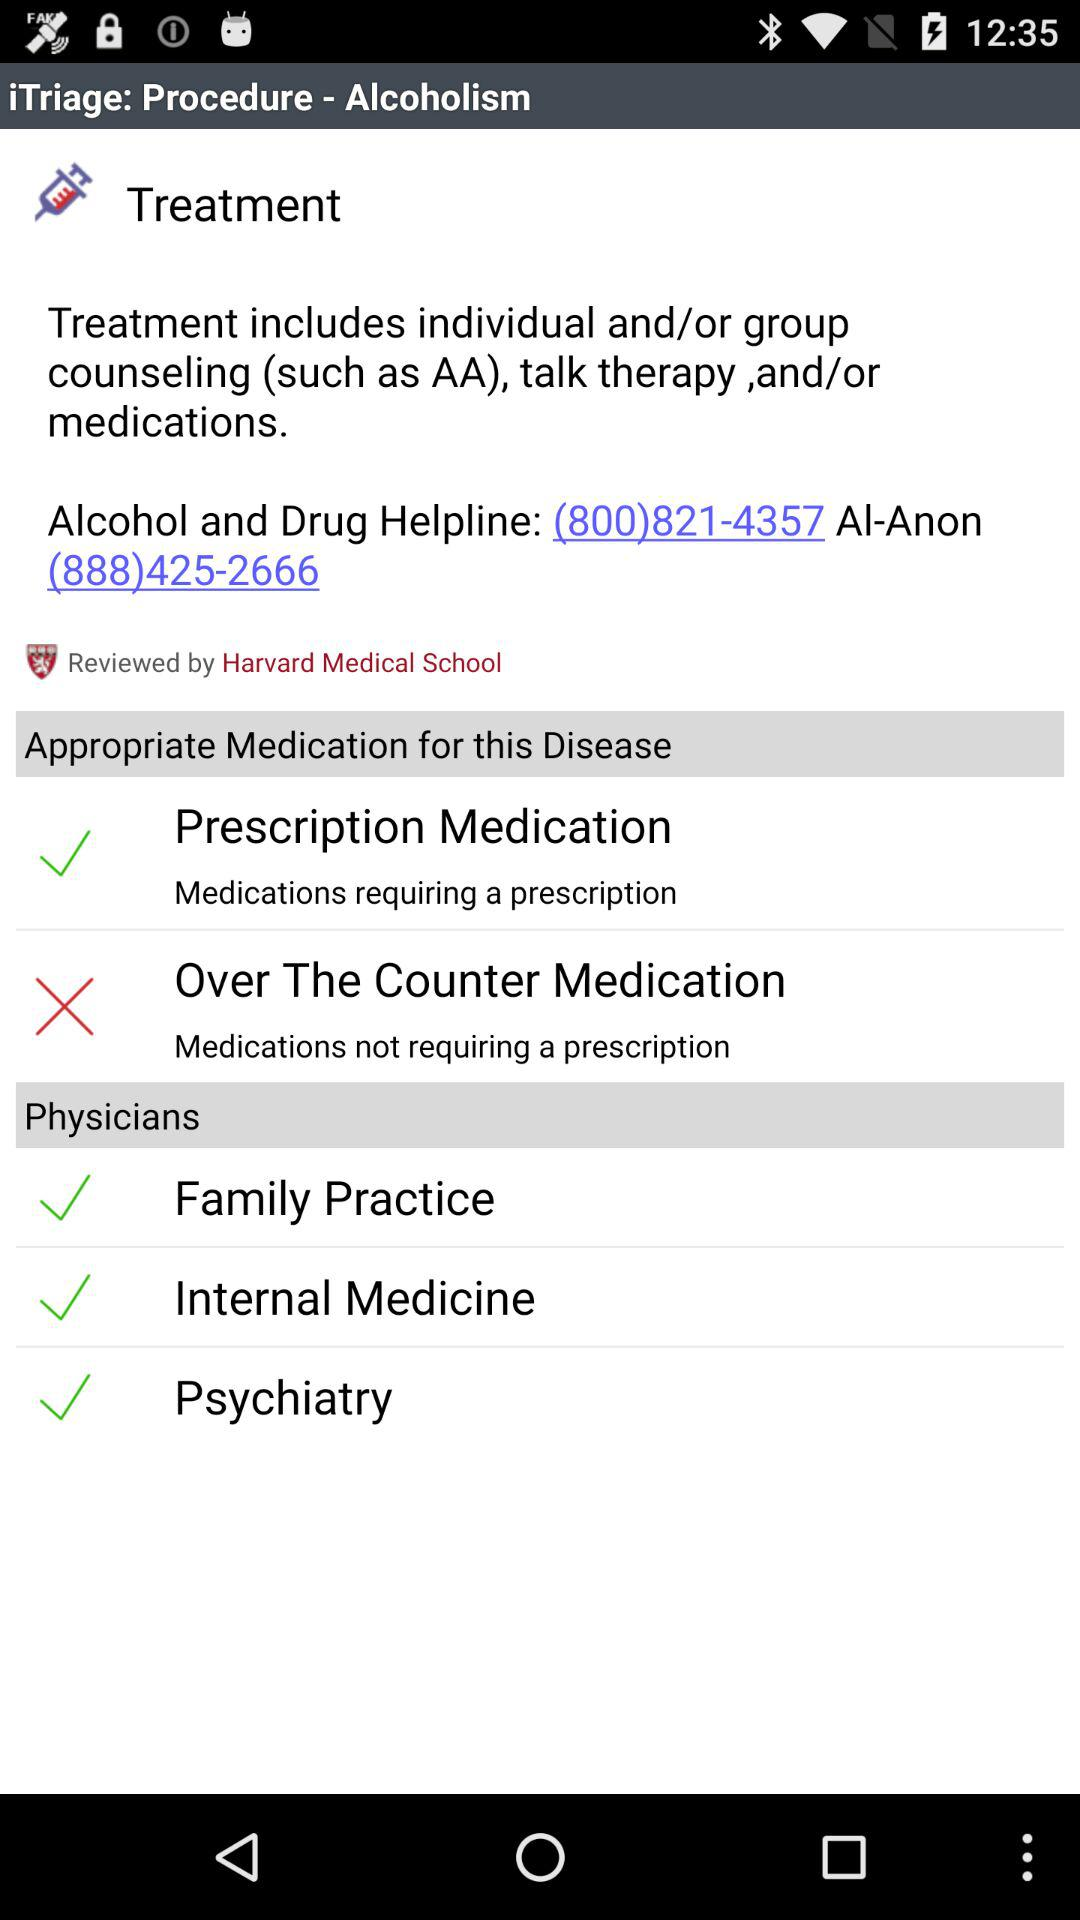What is the appropriate medication for the disease? The appropriate medication for the disease is "Prescription Medication". 